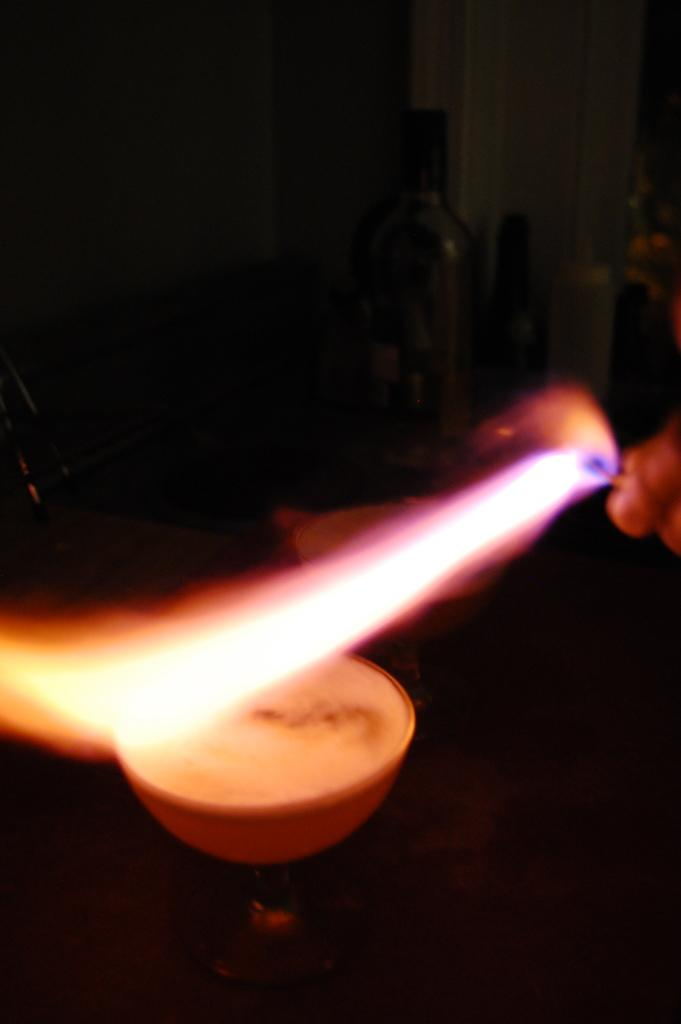What is present in the image? There is a person in the image. What is the person holding in the image? The person is holding a matchstick. What is the condition of the matchstick? The matchstick has fire. What type of bean is being used as a throne for the queen in the image? There is no queen or bean present in the image; it features a person holding a matchstick with fire. 